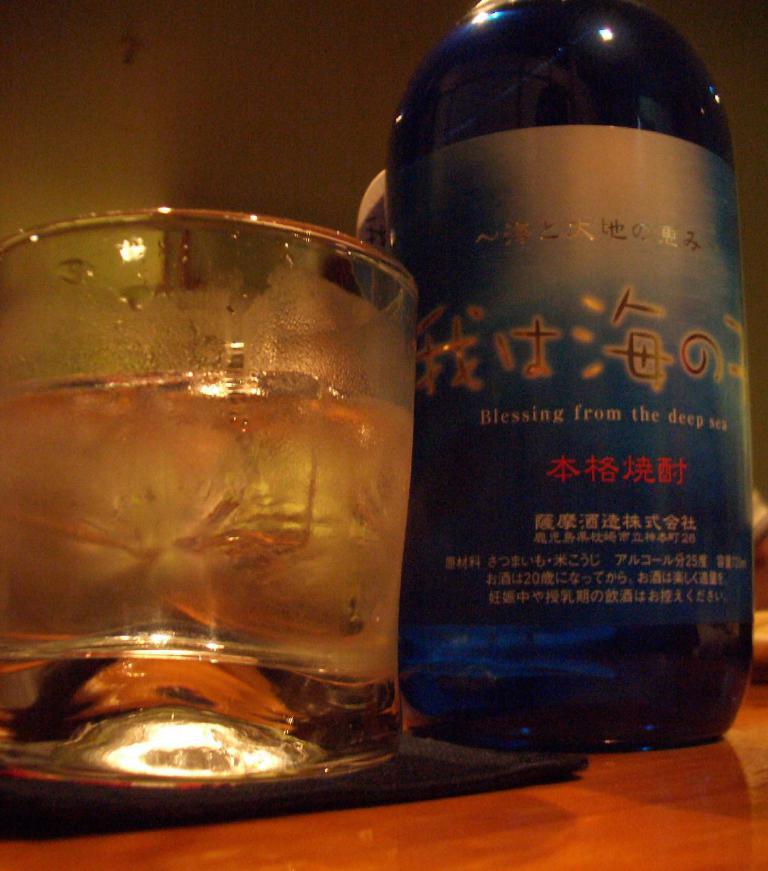Is this a sake best served chilled?
Ensure brevity in your answer.  Answering does not require reading text in the image. 